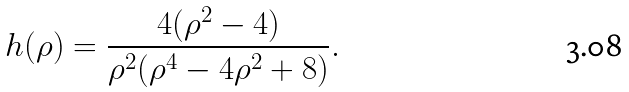<formula> <loc_0><loc_0><loc_500><loc_500>h ( \rho ) = \frac { 4 ( \rho ^ { 2 } - 4 ) } { \rho ^ { 2 } ( \rho ^ { 4 } - 4 \rho ^ { 2 } + 8 ) } .</formula> 